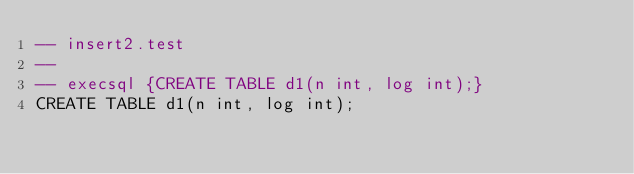<code> <loc_0><loc_0><loc_500><loc_500><_SQL_>-- insert2.test
-- 
-- execsql {CREATE TABLE d1(n int, log int);}
CREATE TABLE d1(n int, log int);</code> 